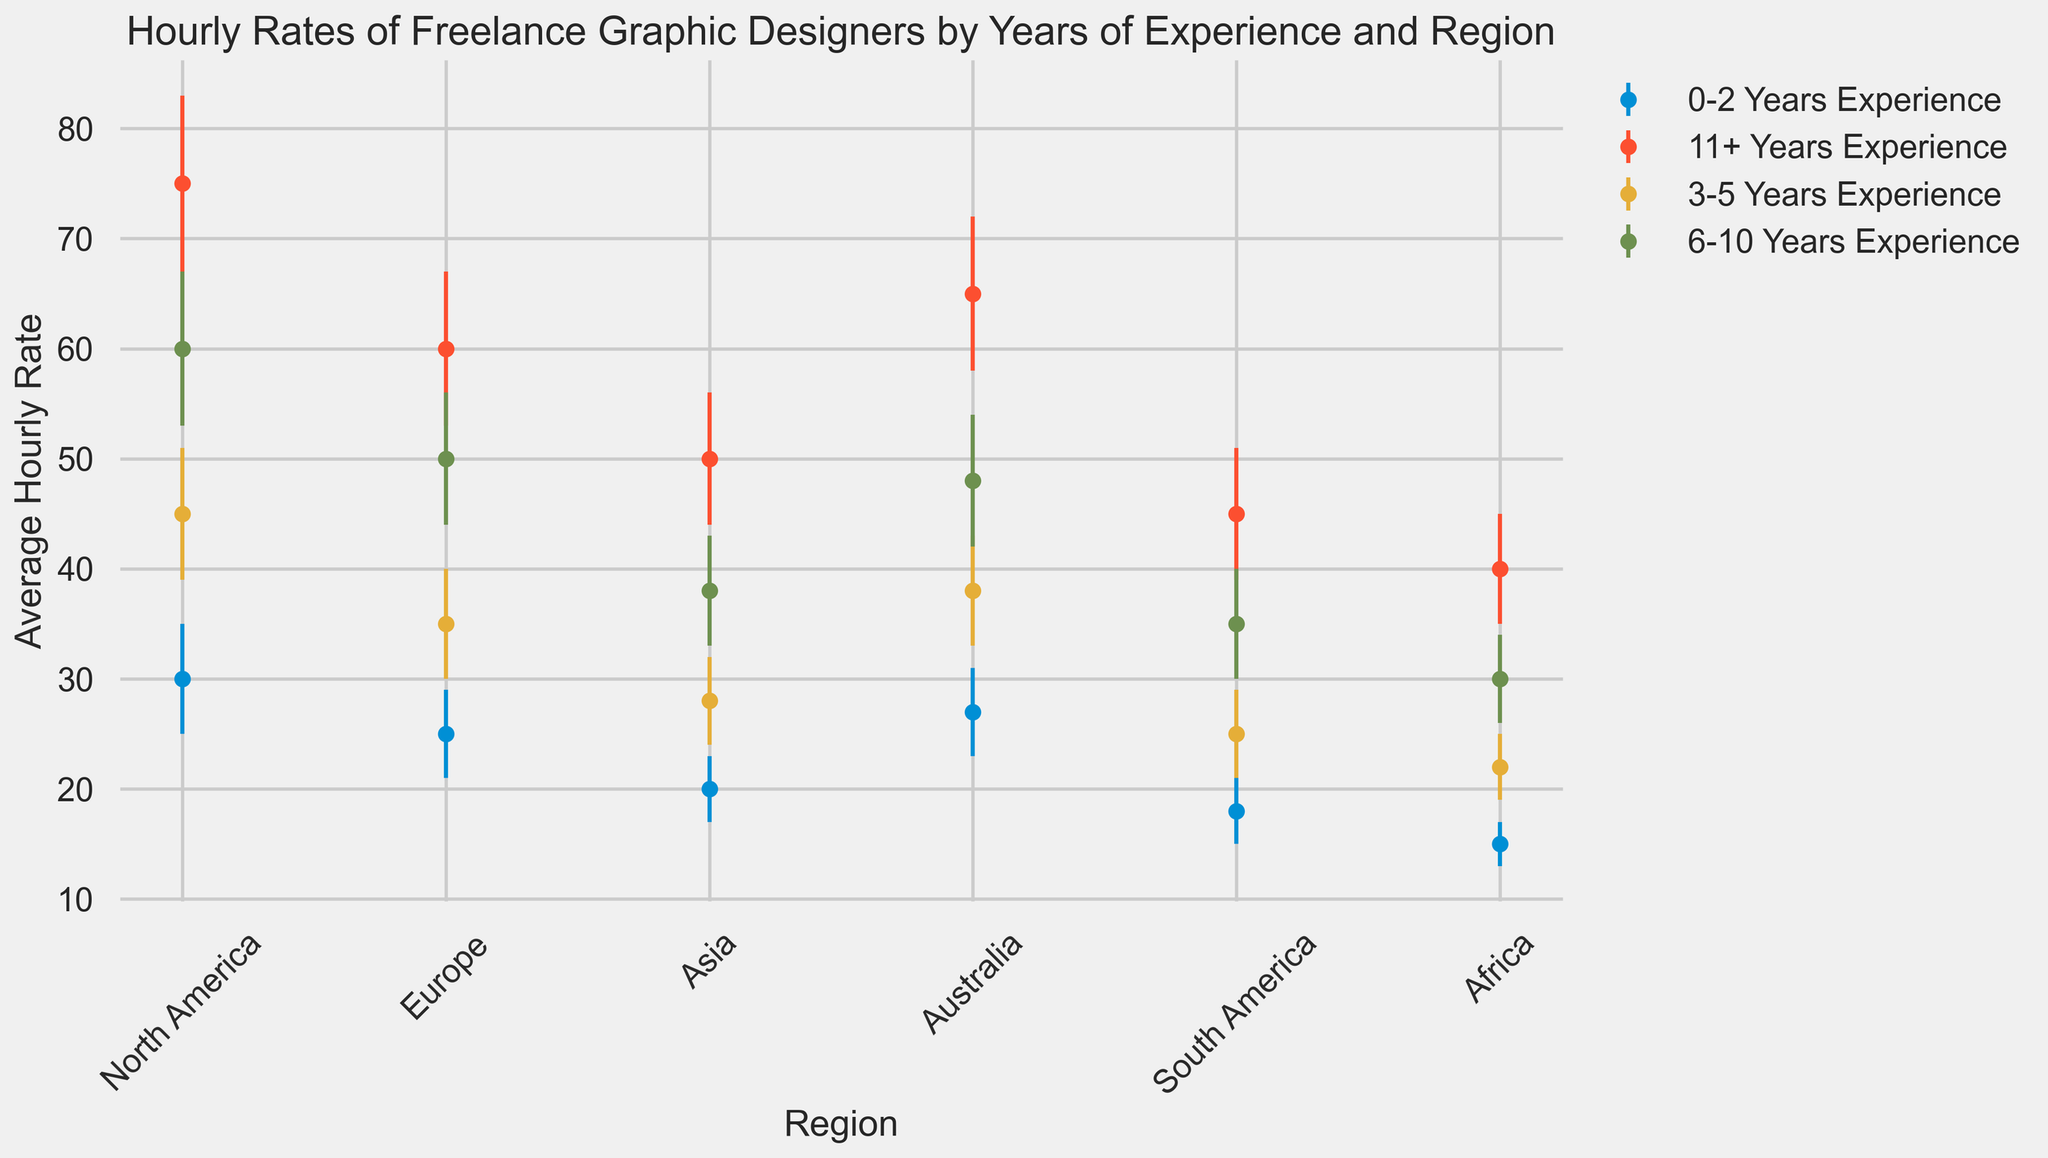What is the average hourly rate for freelance graphic designers with 6-10 years of experience in Asia? The figure shows the average hourly rate for Asia under the 6-10 years experience category.
Answer: 38 Which region has the lowest average hourly rate for designers with 0-2 years of experience? Identify the region with the smallest average hourly rate within the 0-2 years experience category.
Answer: Africa How does the average hourly rate for a designer with 3-5 years of experience in Europe compare to one with 3-5 years of experience in Asia? Compare the average hourly rates in Europe and Asia within the 3-5 years experience category.
Answer: Europe is higher What is the difference in the average hourly rate between North America and South America for designers with 11+ years of experience? Subtract the average hourly rate of South America from North America in the 11+ years experience category.
Answer: 30 What visual marker or characteristic helps indicate the uncertainty or variability in the data? The figure uses error bars to represent the standard deviation, illustrating the uncertainty in the average hourly rates.
Answer: Error bars Which region shows the highest average hourly rate for designers with 11+ years of experience? Identify the region with the highest average hourly rate in the 11+ years experience category.
Answer: North America How does the average rate trend change as experience increases in Australia between 0-2 and 11+ years? Observe the trend for average hourly rates in Australia across all experience categories from 0-2 years to 11+ years.
Answer: The rate increases What is the combined average hourly rate of designers with 3-5 years of experience in North America and Australia? Add the average hourly rates for North America and Australia within the 3-5 years experience category.
Answer: 83 Which years of experience category shows the least variation in hourly rates across different regions? Compare the lengths of the error bars across different experience categories and regions to find the smallest variation.
Answer: 0-2 years What is the average hourly rate difference between Europe and Africa for designers with 6-10 years of experience? Subtract Africa's average hourly rate from Europe's average hourly rate within the 6-10 years experience category.
Answer: 20 